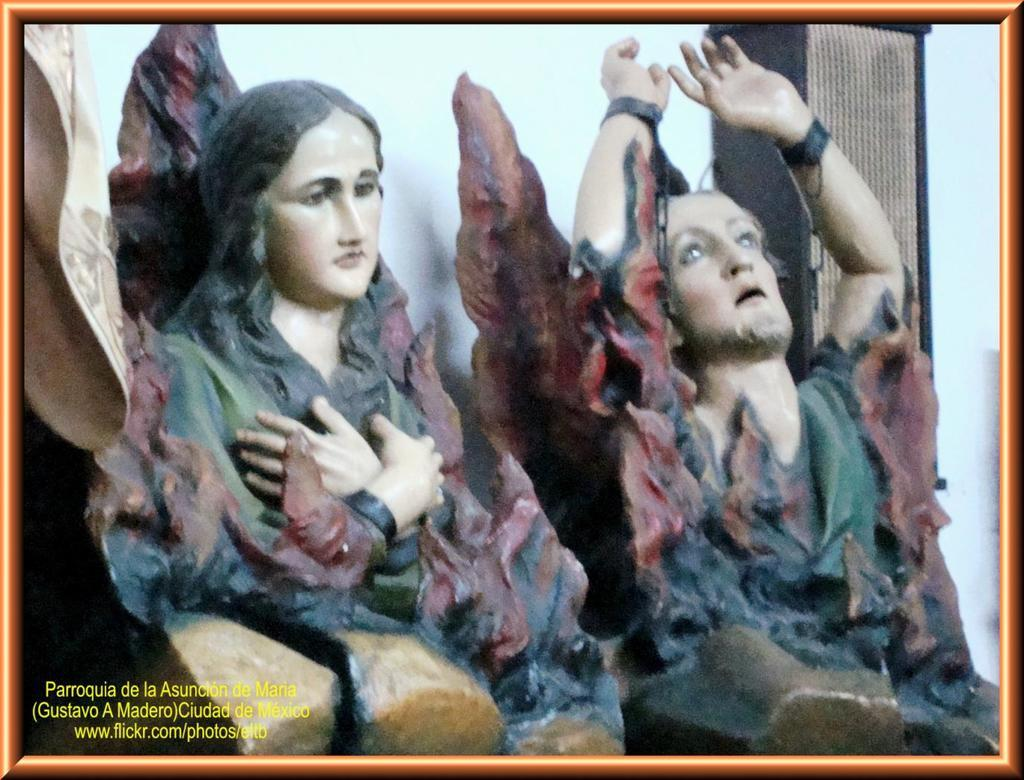What is the main subject of the image? The main subject of the image is sculptures of people in the center. Are there any words or phrases in the image? Yes, there is some text in the image. What other architectural feature can be seen in the image? There is a pillar in the image. How does the crowd affect the profit of the sculptures in the image? There is no mention of a crowd or profit in the image, so it is not possible to answer that question. 